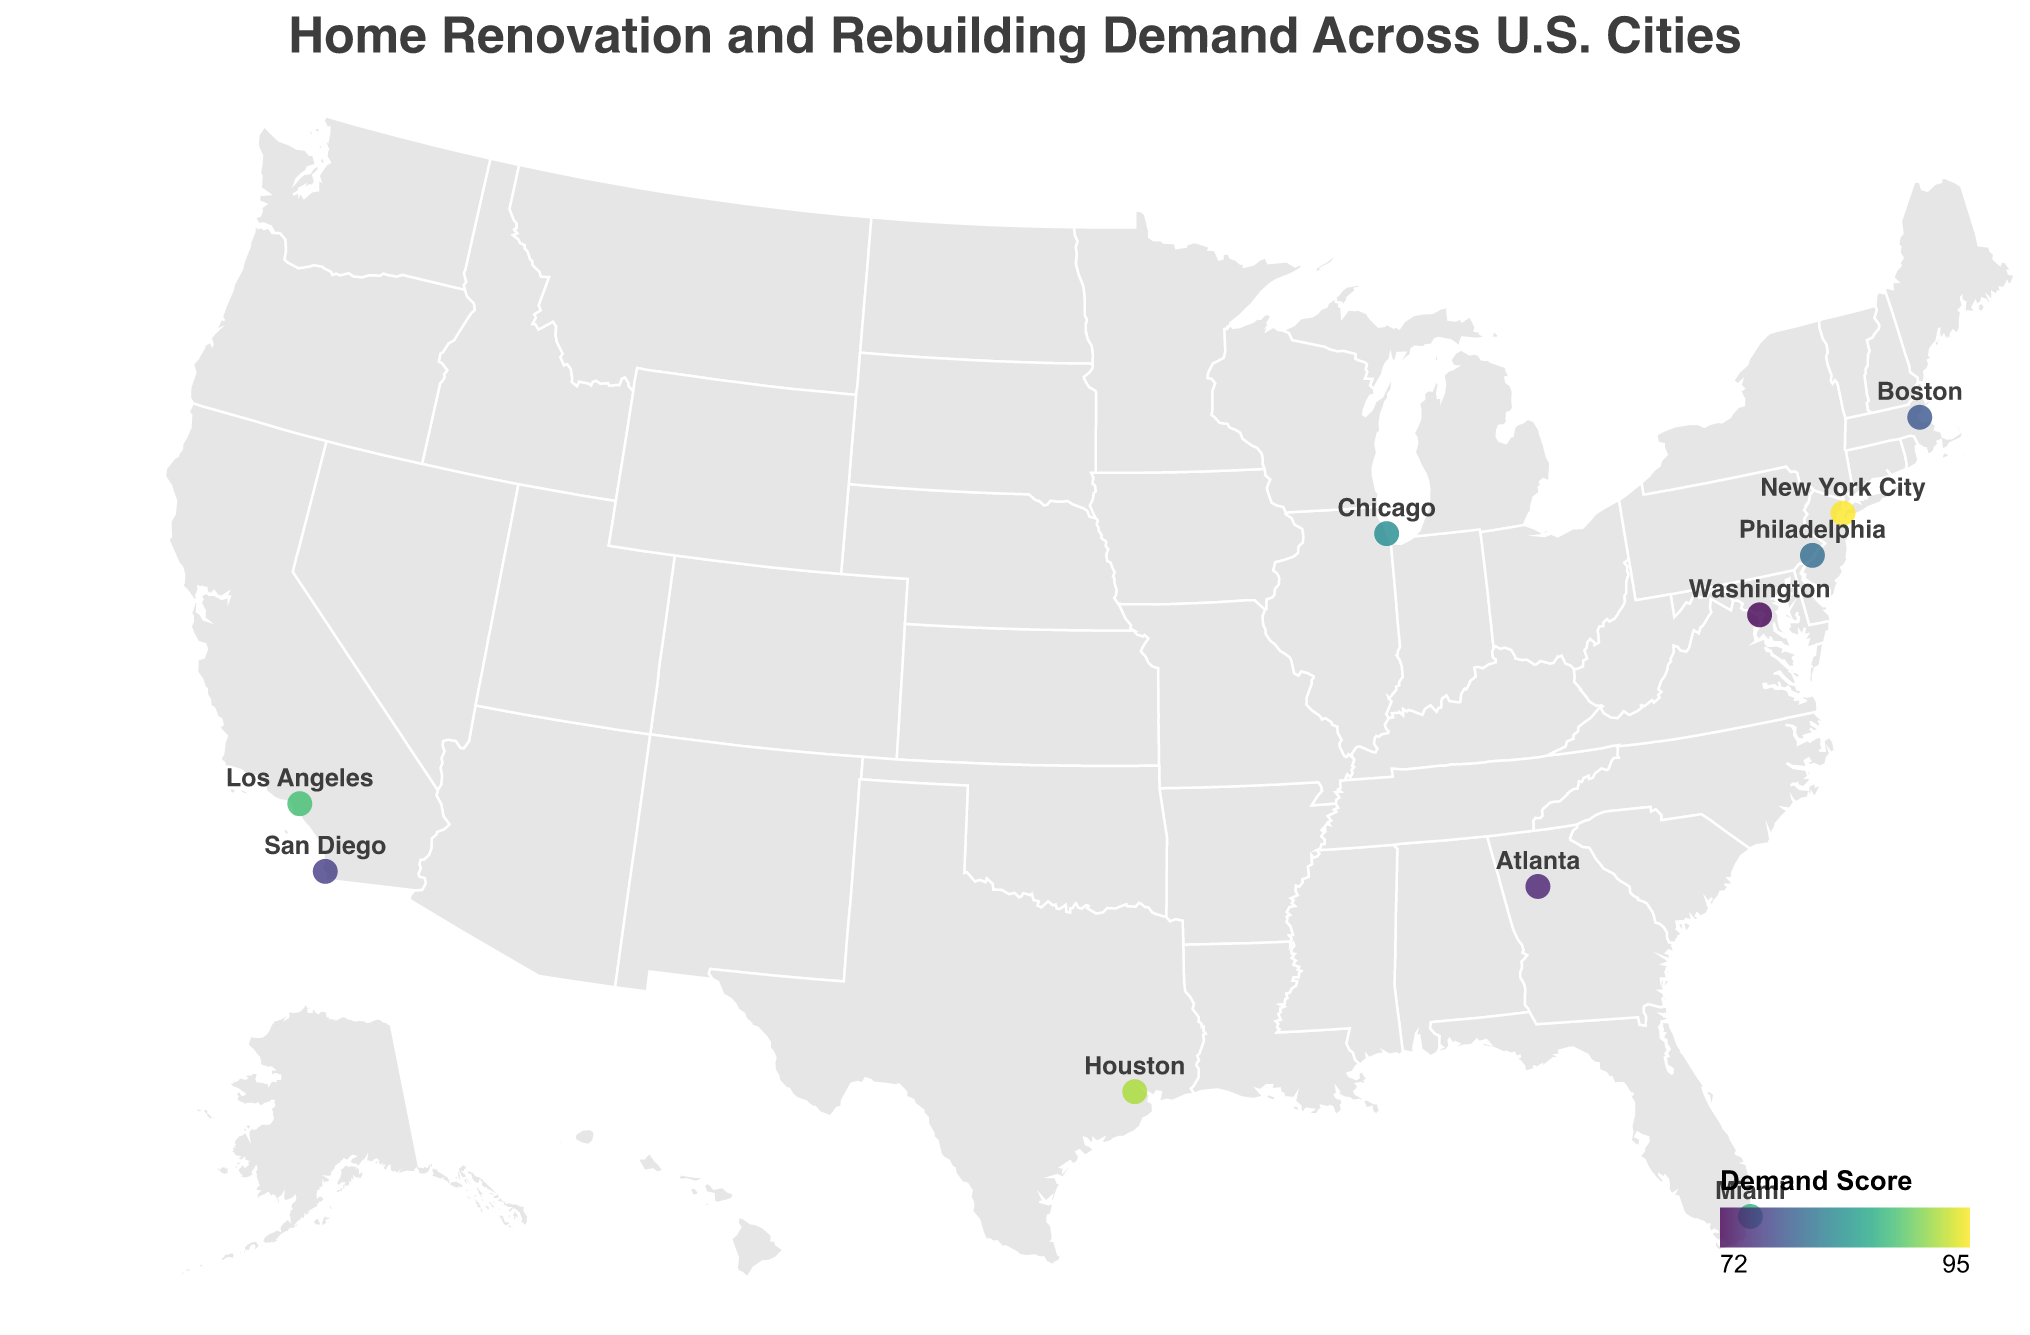What is the title of the figure? The title is located at the top of the figure, usually in a larger font and descriptive of the content shown.
Answer: "Home Renovation and Rebuilding Demand Across U.S. Cities" How many cities are plotted on the figure? Each city represents a data point on the map, and you can count the number of distinct city names shown.
Answer: 10 Which city has the highest demand score, and what is its primary reason? Look at the data points on the map and identify the one with the highest demand score, then find the corresponding city and primary reason.
Answer: New York City, Hurricane damage What is the range of demand scores across the cities plotted? The range is calculated by finding the highest and lowest demand scores and subtracting the lowest from the highest. The highest score is 95, and the lowest is 72, so the range is 95 - 72.
Answer: 23 Which state has more than one city listed, and which cities are they? Scan the states associated with each city to identify any state that appears more than once, and then list the corresponding cities.
Answer: California: Los Angeles and San Diego What is the average demand score across all cities? Sum all the demand scores and then divide by the number of cities. The scores are: 95, 92, 88, 87, 83, 80, 78, 76, 74, 72. So, (95+92+88+87+83+80+78+76+74+72) / 10 = 82.5.
Answer: 82.5 Which city has the lowest demand score, and what is its primary reason? Look at the data points for the city with the lowest demand score, then find the corresponding city and primary reason.
Answer: Washington, D.C., Government building upgrades How do the demand scores for New York City and Miami compare? Identify the demand scores for both cities and compare them directly. New York City has a score of 95, and Miami has a score of 87.
Answer: New York City has a higher demand score than Miami What is the primary reason for need in Los Angeles, and what is its demand score? Locate Los Angeles on the map, then find its primary reason and demand score from the tooltip or legend.
Answer: Earthquake retrofitting, 88 